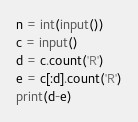Convert code to text. <code><loc_0><loc_0><loc_500><loc_500><_Python_>n = int(input())
c = input()
d = c.count('R')
e = c[:d].count('R')
print(d-e)</code> 